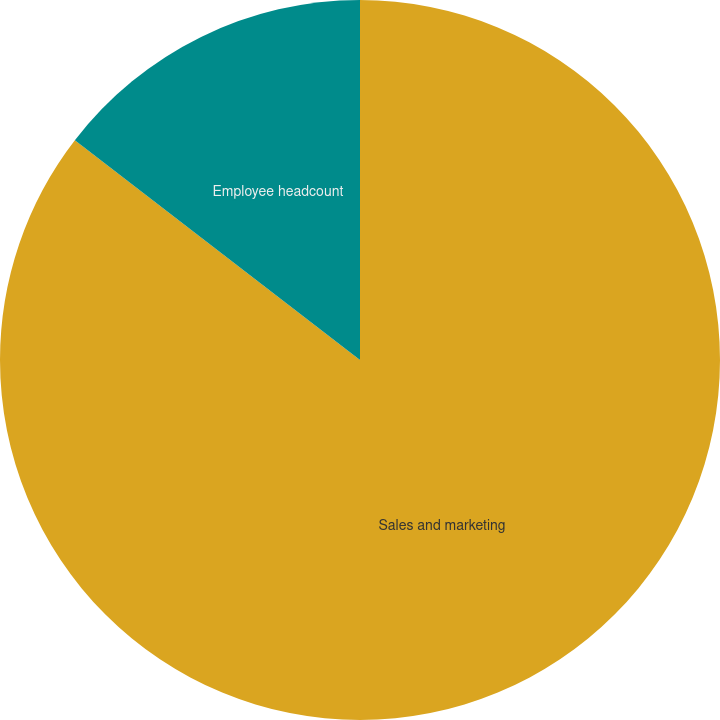Convert chart. <chart><loc_0><loc_0><loc_500><loc_500><pie_chart><fcel>Sales and marketing<fcel>Employee headcount<nl><fcel>85.45%<fcel>14.55%<nl></chart> 